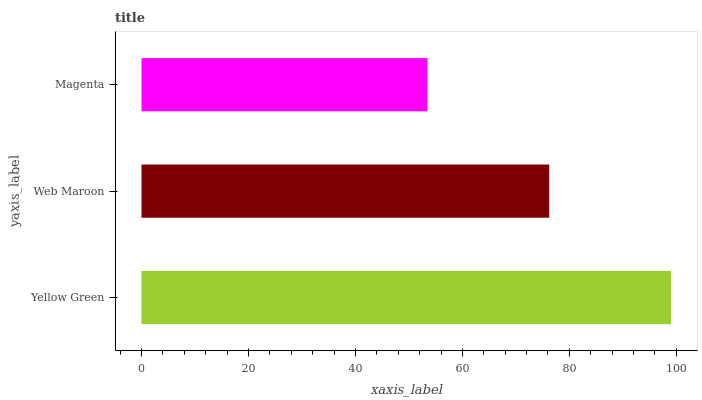Is Magenta the minimum?
Answer yes or no. Yes. Is Yellow Green the maximum?
Answer yes or no. Yes. Is Web Maroon the minimum?
Answer yes or no. No. Is Web Maroon the maximum?
Answer yes or no. No. Is Yellow Green greater than Web Maroon?
Answer yes or no. Yes. Is Web Maroon less than Yellow Green?
Answer yes or no. Yes. Is Web Maroon greater than Yellow Green?
Answer yes or no. No. Is Yellow Green less than Web Maroon?
Answer yes or no. No. Is Web Maroon the high median?
Answer yes or no. Yes. Is Web Maroon the low median?
Answer yes or no. Yes. Is Magenta the high median?
Answer yes or no. No. Is Yellow Green the low median?
Answer yes or no. No. 